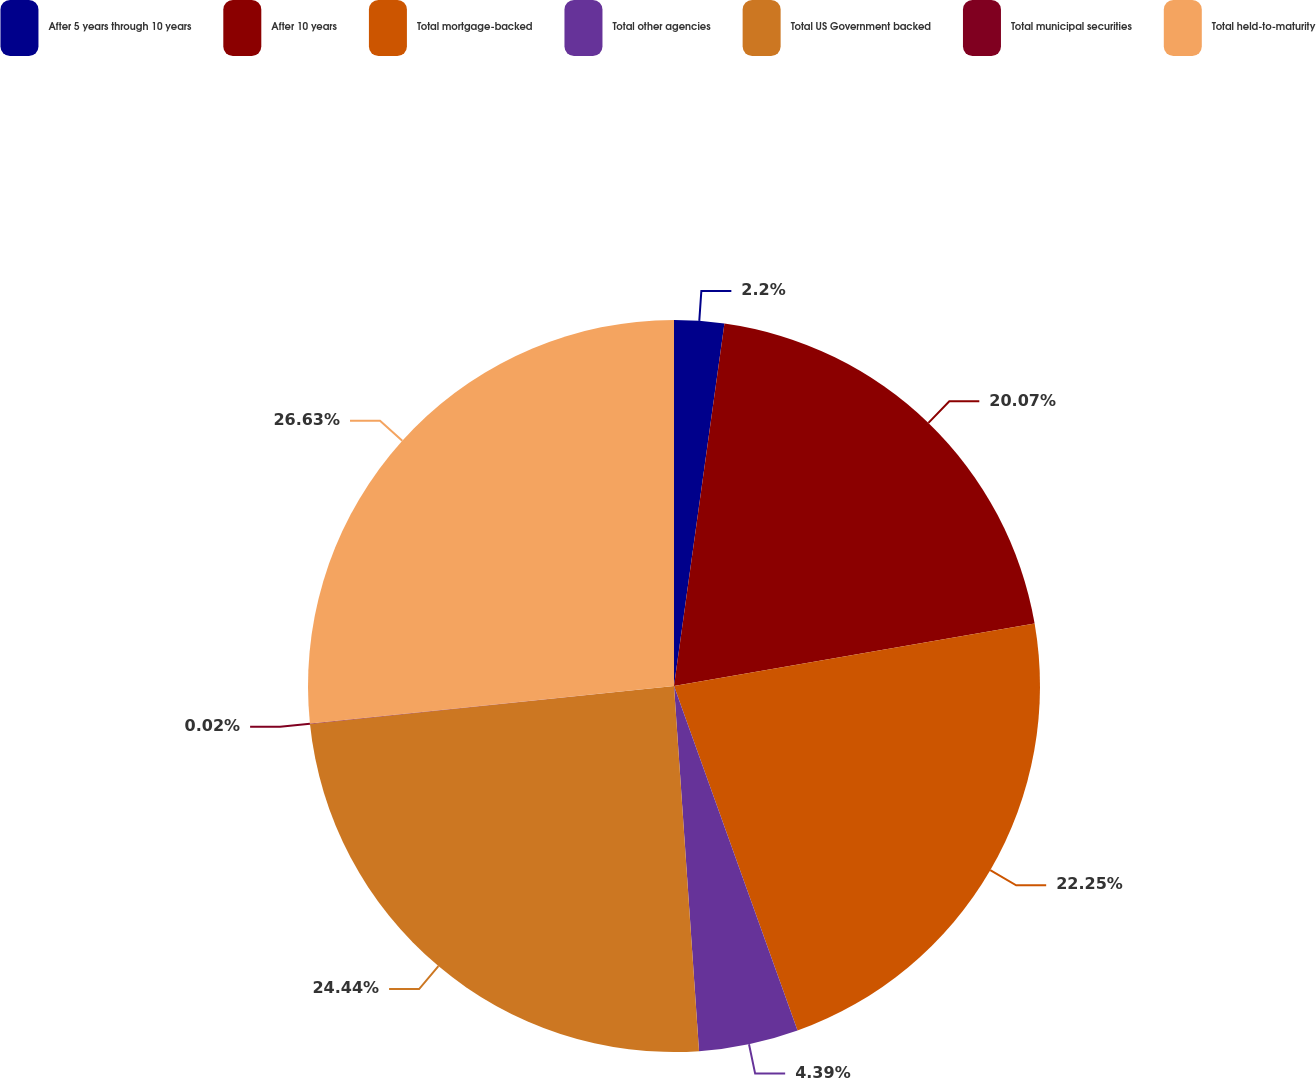<chart> <loc_0><loc_0><loc_500><loc_500><pie_chart><fcel>After 5 years through 10 years<fcel>After 10 years<fcel>Total mortgage-backed<fcel>Total other agencies<fcel>Total US Government backed<fcel>Total municipal securities<fcel>Total held-to-maturity<nl><fcel>2.2%<fcel>20.07%<fcel>22.25%<fcel>4.39%<fcel>24.44%<fcel>0.02%<fcel>26.63%<nl></chart> 